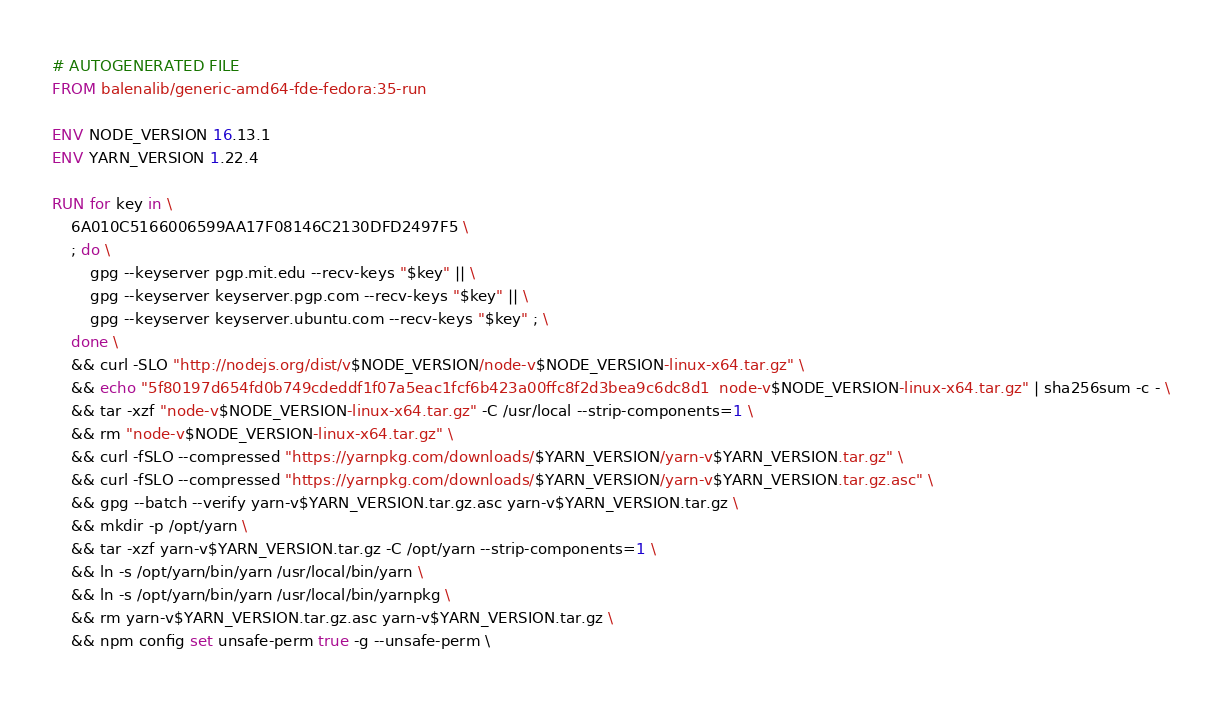Convert code to text. <code><loc_0><loc_0><loc_500><loc_500><_Dockerfile_># AUTOGENERATED FILE
FROM balenalib/generic-amd64-fde-fedora:35-run

ENV NODE_VERSION 16.13.1
ENV YARN_VERSION 1.22.4

RUN for key in \
	6A010C5166006599AA17F08146C2130DFD2497F5 \
	; do \
		gpg --keyserver pgp.mit.edu --recv-keys "$key" || \
		gpg --keyserver keyserver.pgp.com --recv-keys "$key" || \
		gpg --keyserver keyserver.ubuntu.com --recv-keys "$key" ; \
	done \
	&& curl -SLO "http://nodejs.org/dist/v$NODE_VERSION/node-v$NODE_VERSION-linux-x64.tar.gz" \
	&& echo "5f80197d654fd0b749cdeddf1f07a5eac1fcf6b423a00ffc8f2d3bea9c6dc8d1  node-v$NODE_VERSION-linux-x64.tar.gz" | sha256sum -c - \
	&& tar -xzf "node-v$NODE_VERSION-linux-x64.tar.gz" -C /usr/local --strip-components=1 \
	&& rm "node-v$NODE_VERSION-linux-x64.tar.gz" \
	&& curl -fSLO --compressed "https://yarnpkg.com/downloads/$YARN_VERSION/yarn-v$YARN_VERSION.tar.gz" \
	&& curl -fSLO --compressed "https://yarnpkg.com/downloads/$YARN_VERSION/yarn-v$YARN_VERSION.tar.gz.asc" \
	&& gpg --batch --verify yarn-v$YARN_VERSION.tar.gz.asc yarn-v$YARN_VERSION.tar.gz \
	&& mkdir -p /opt/yarn \
	&& tar -xzf yarn-v$YARN_VERSION.tar.gz -C /opt/yarn --strip-components=1 \
	&& ln -s /opt/yarn/bin/yarn /usr/local/bin/yarn \
	&& ln -s /opt/yarn/bin/yarn /usr/local/bin/yarnpkg \
	&& rm yarn-v$YARN_VERSION.tar.gz.asc yarn-v$YARN_VERSION.tar.gz \
	&& npm config set unsafe-perm true -g --unsafe-perm \</code> 